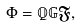<formula> <loc_0><loc_0><loc_500><loc_500>\Phi = \mathbb { Q } \mathbb { G } \mathfrak { F } ,</formula> 